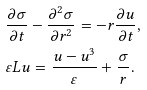<formula> <loc_0><loc_0><loc_500><loc_500>& \frac { \partial \sigma } { \partial t } - \frac { \partial ^ { 2 } \sigma } { \partial r ^ { 2 } } = - r \frac { \partial u } { \partial t } , \\ & \varepsilon L u = \frac { u - u ^ { 3 } } { \varepsilon } + \frac { \sigma } { r } .</formula> 